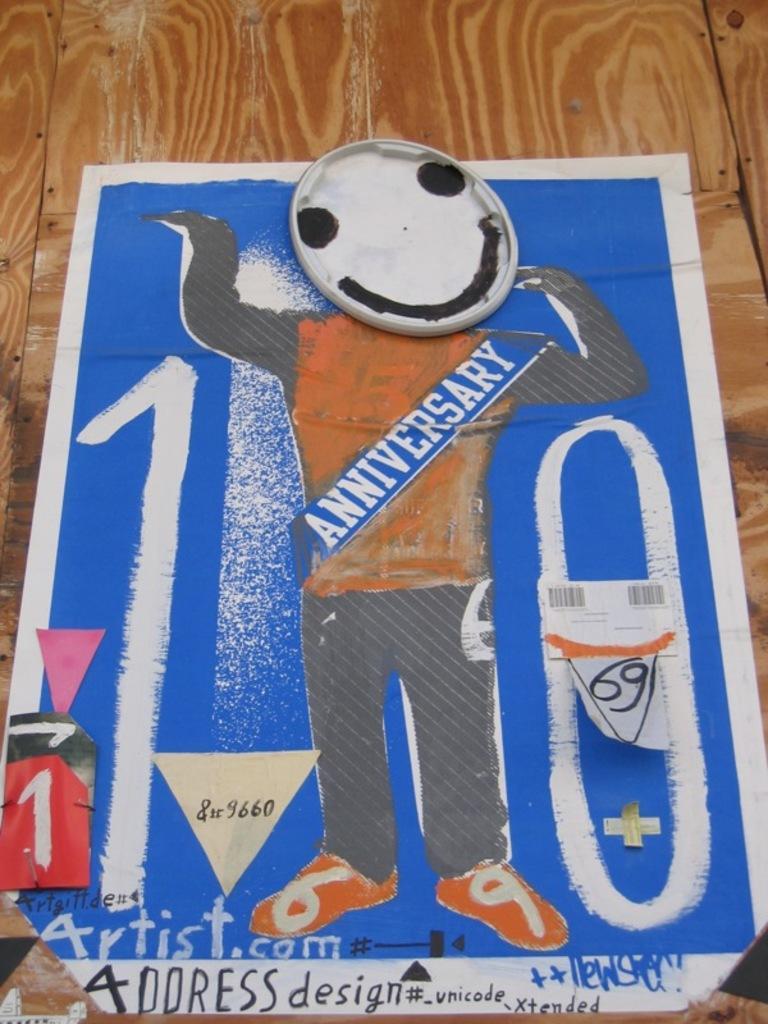Can you describe this image briefly? In this image I can see a poster which is blue, black, white and orange in color on the wooden surface which is brown and cream in color. 